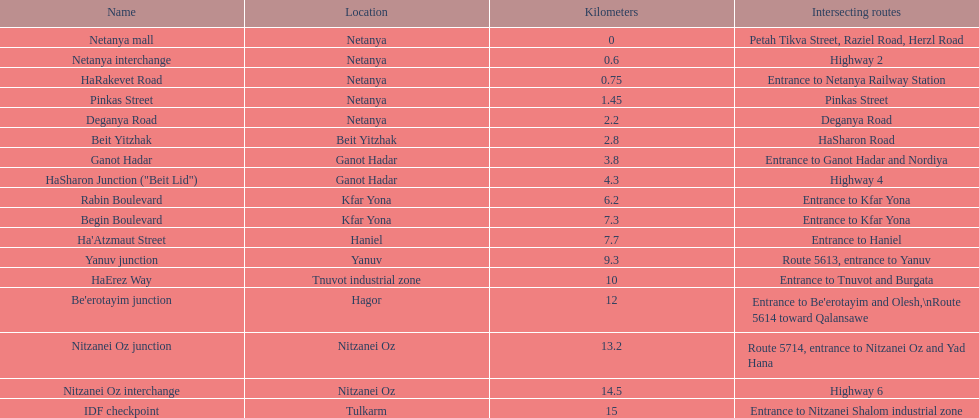What is the intersecting route of rabin boulevard? Entrance to Kfar Yona. Which portion has this intersecting route? Begin Boulevard. 